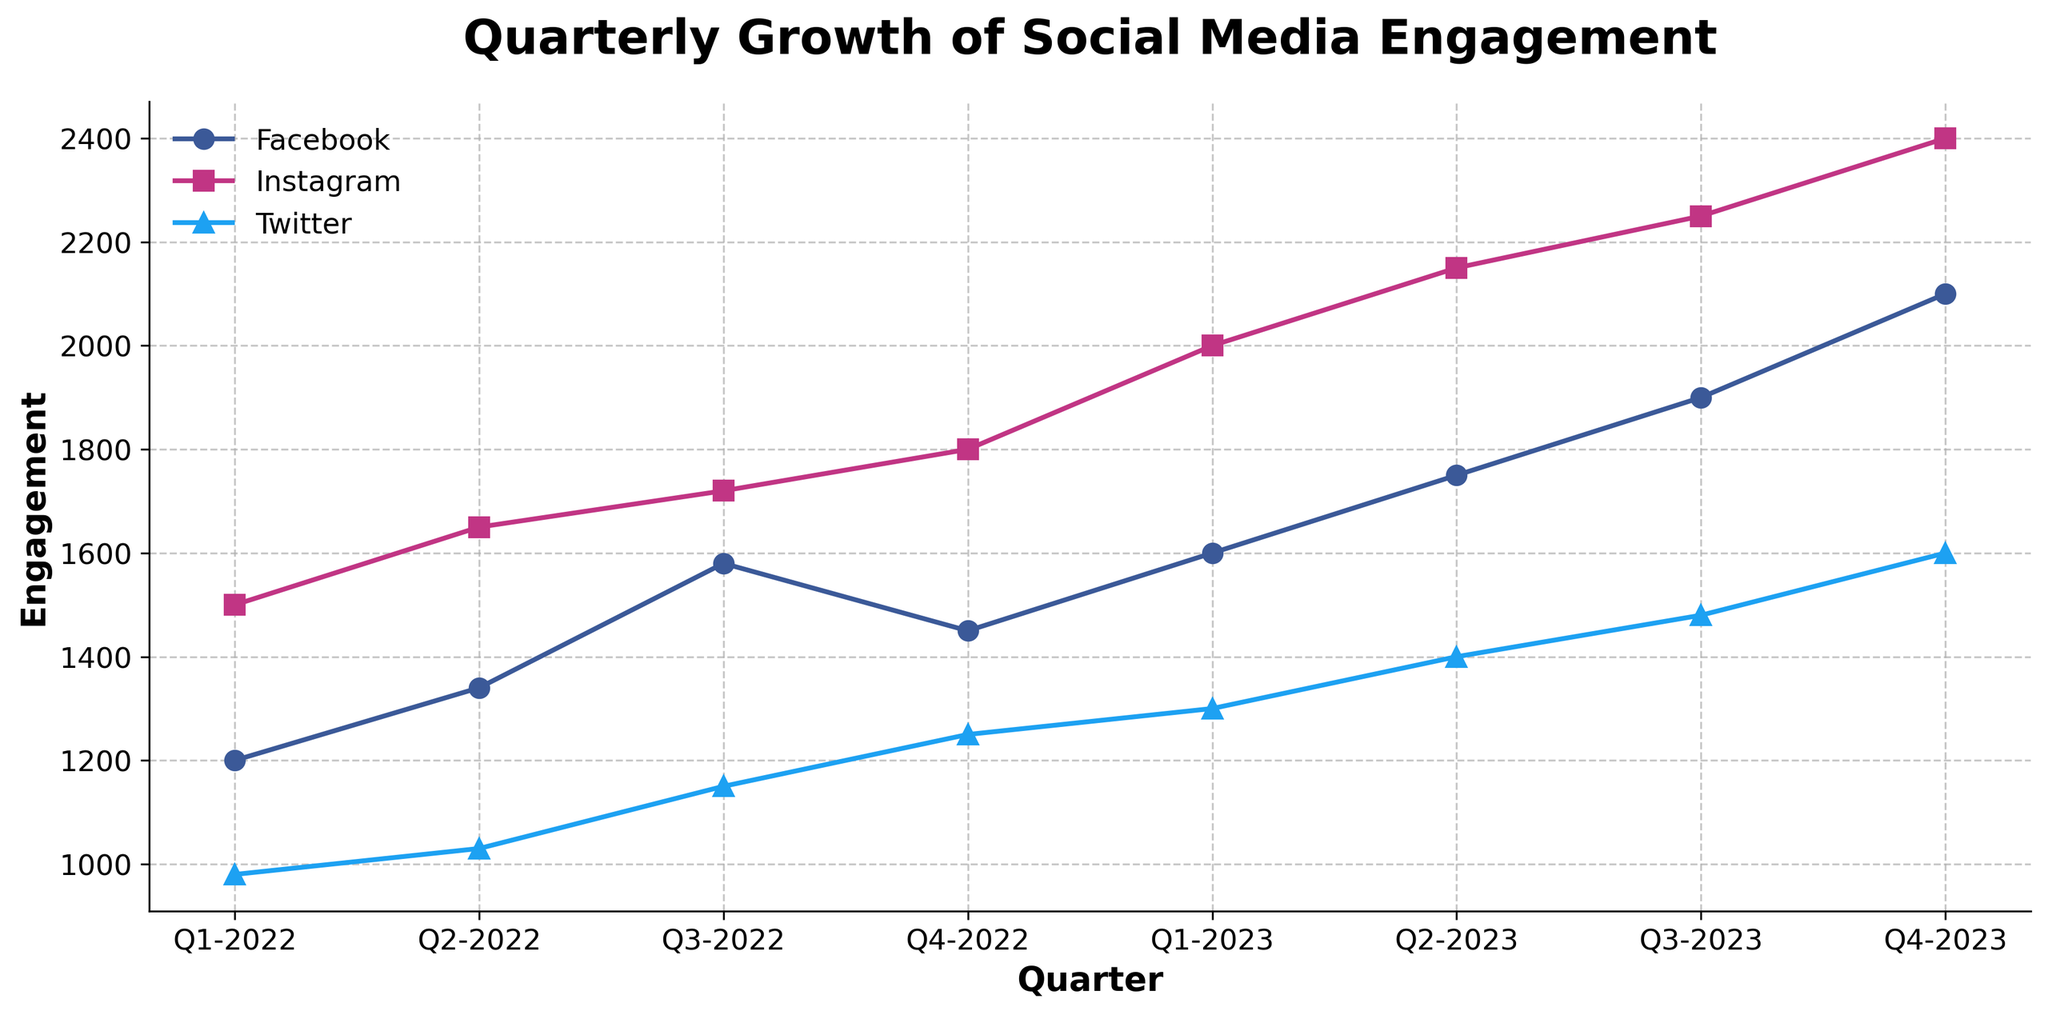What is the title of the figure? The title is at the top of the figure and usually provides a summary of what the chart represents.
Answer: Quarterly Growth of Social Media Engagement Which social media platform experienced the highest engagement in Q2-2022? By looking at the data points for Q2-2022 and comparing them among Facebook, Instagram, and Twitter, we see that Instagram has the highest engagement.
Answer: Instagram What is the color used for the Facebook engagement line? The color of the line representing Facebook is a visual element on the chart.
Answer: Blue How many quarters are displayed in the figure? Count the number of distinct data points on the x-axis, which are labeled by quarters.
Answer: 8 What was the engagement for Twitter in Q4-2023? Locate Q4-2023 on the x-axis and check the corresponding data point for Twitter.
Answer: 1,600 What is the total engagement for Instagram across all quarters? Sum the engagement values for Instagram from Q1-2022 to Q4-2023: 1500+1650+1720+1800+2000+2150+2250+2400.
Answer: 15,470 Which platform had the smallest variance in growth over the period? Review each line's growth trend for consistency; Twitter's growth is more linear and less variable compared to Facebook and Instagram.
Answer: Twitter Between Q3-2022 and Q4-2022, did any platform see a decrease in engagement? Look at the trend between Q3-2022 and Q4-2022 for all three platforms. Facebook shows a decrease in engagement.
Answer: Facebook 